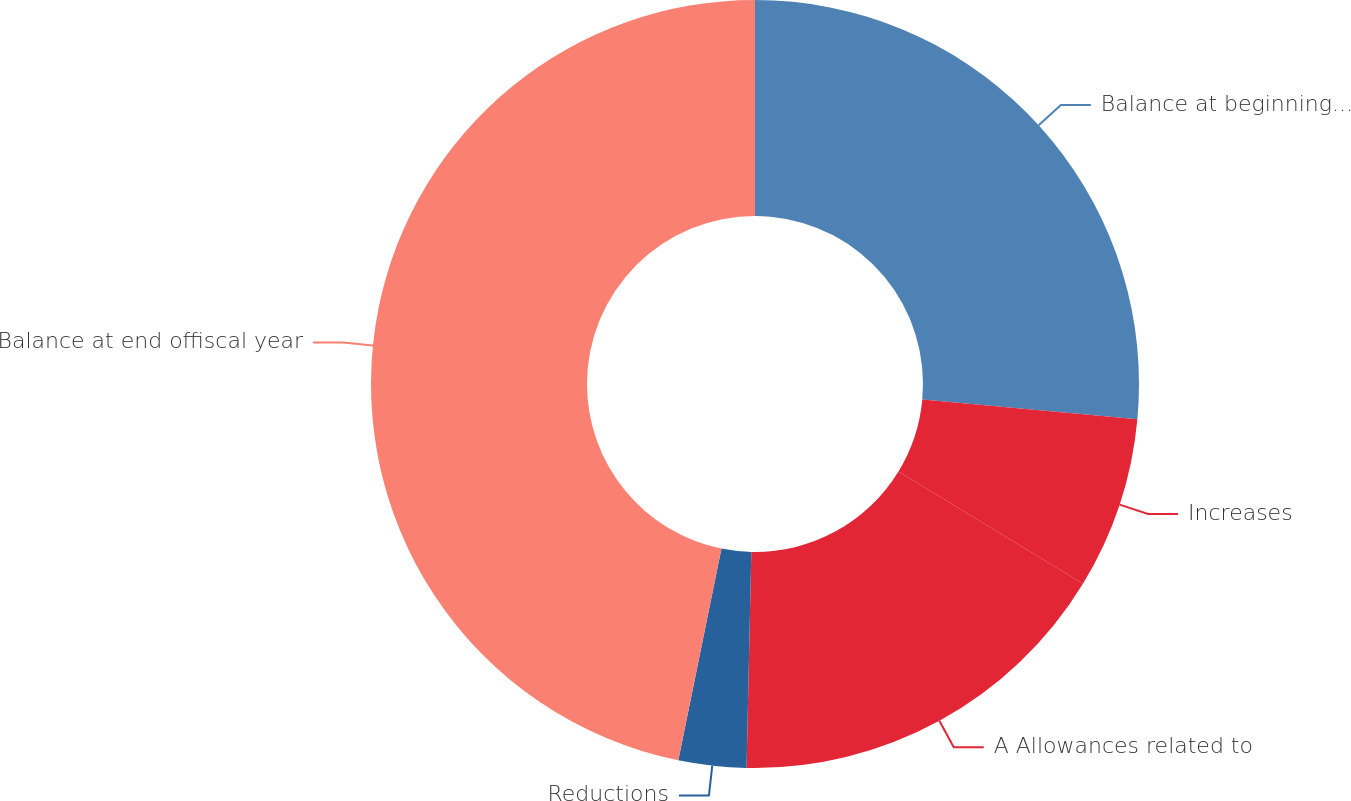Convert chart to OTSL. <chart><loc_0><loc_0><loc_500><loc_500><pie_chart><fcel>Balance at beginning offiscal<fcel>Increases<fcel>A Allowances related to<fcel>Reductions<fcel>Balance at end offiscal year<nl><fcel>26.46%<fcel>7.25%<fcel>16.64%<fcel>2.85%<fcel>46.8%<nl></chart> 